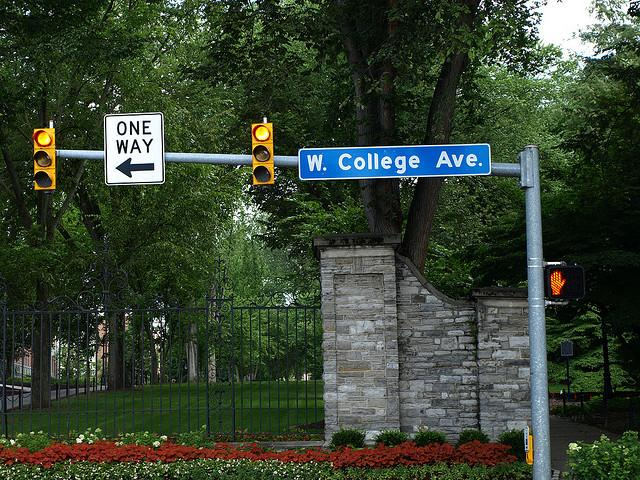What color is the light shown on top of the traffic lights of College Avenue? yellow 